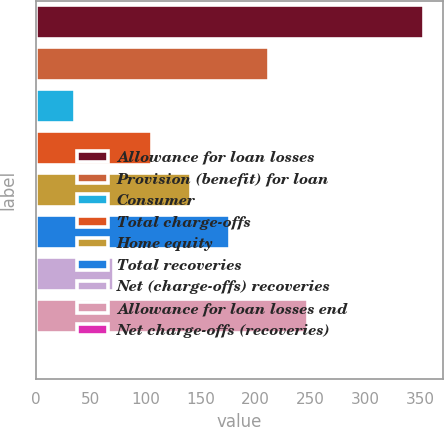<chart> <loc_0><loc_0><loc_500><loc_500><bar_chart><fcel>Allowance for loan losses<fcel>Provision (benefit) for loan<fcel>Consumer<fcel>Total charge-offs<fcel>Home equity<fcel>Total recoveries<fcel>Net (charge-offs) recoveries<fcel>Allowance for loan losses end<fcel>Net charge-offs (recoveries)<nl><fcel>353<fcel>211.96<fcel>35.66<fcel>106.18<fcel>141.44<fcel>176.7<fcel>70.92<fcel>247.22<fcel>0.4<nl></chart> 